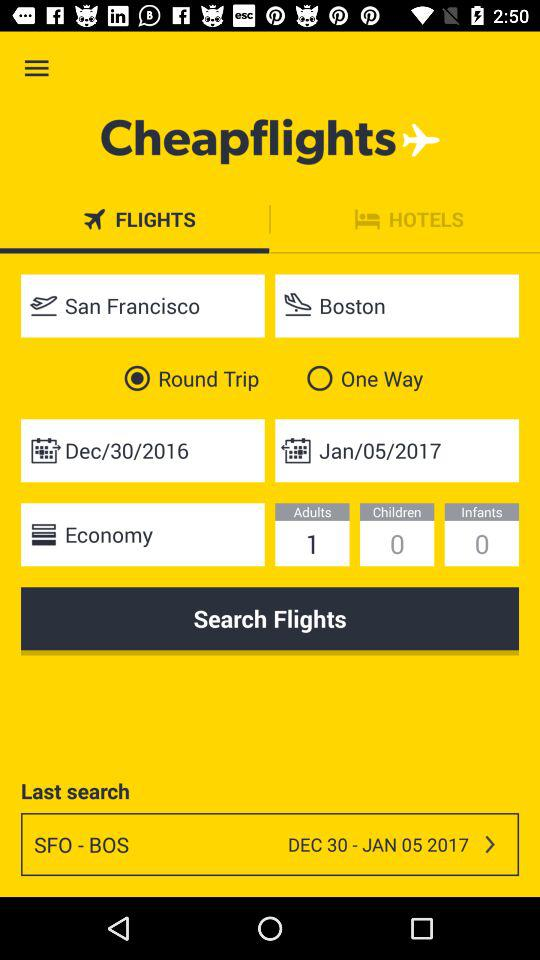How many adults will be traveling? There will be only 1 adult traveling. 